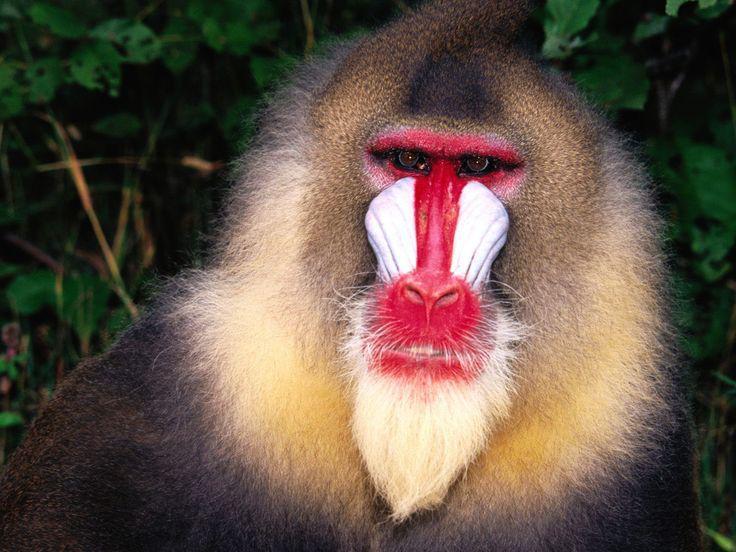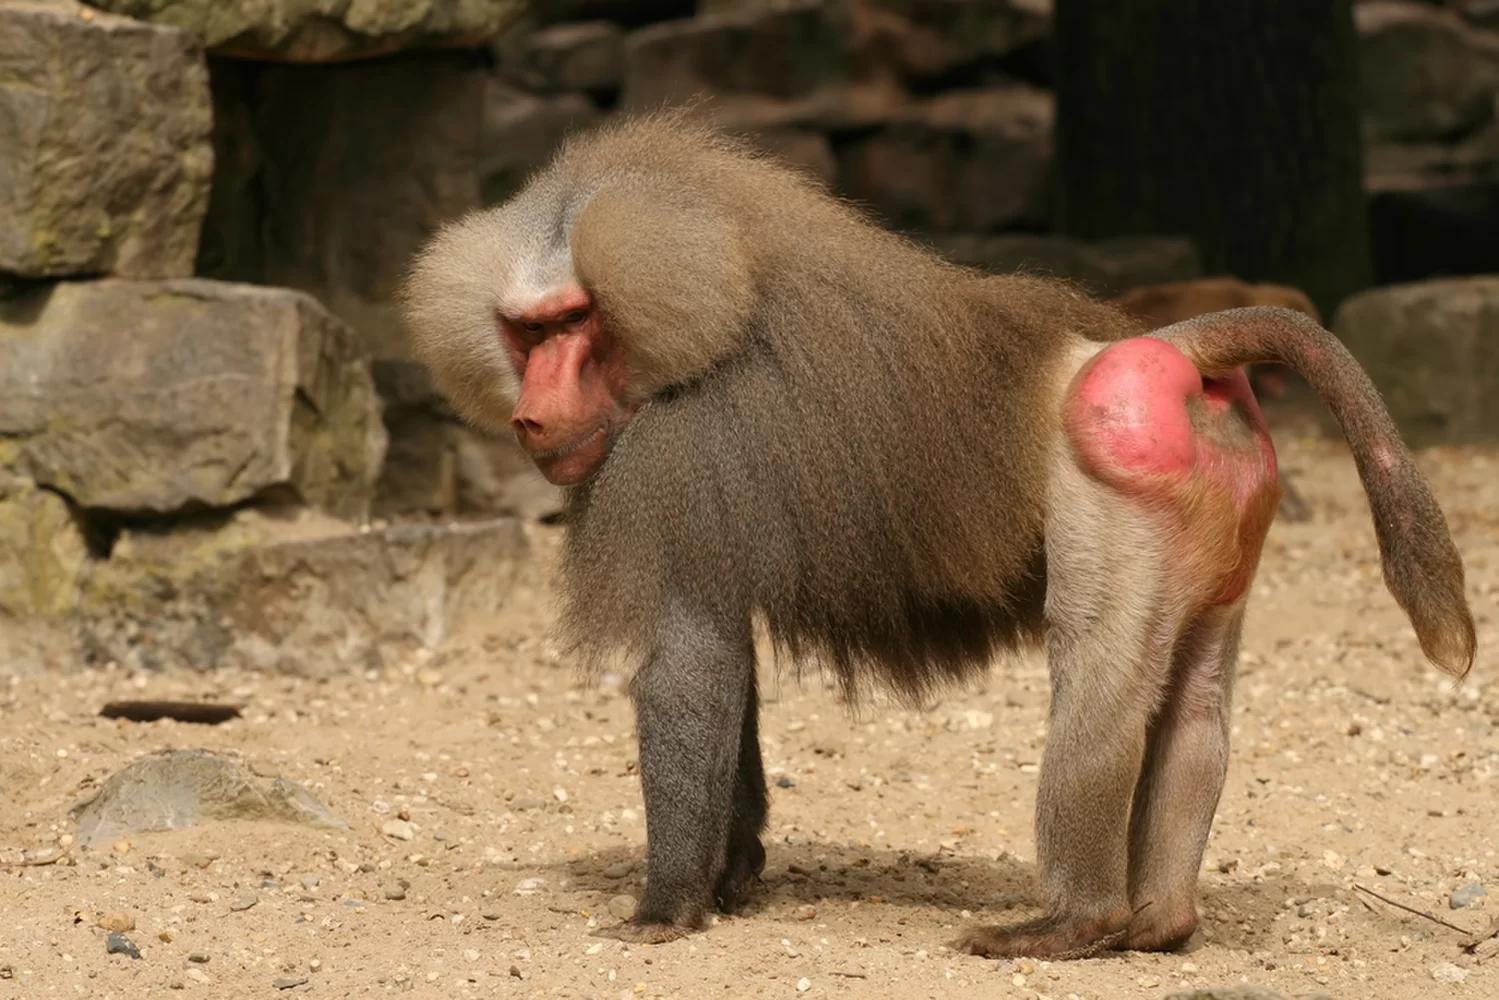The first image is the image on the left, the second image is the image on the right. Evaluate the accuracy of this statement regarding the images: "A baboon is standing on all fours with its tail and pink rear angled toward the camera and its head turned.". Is it true? Answer yes or no. Yes. The first image is the image on the left, the second image is the image on the right. For the images shown, is this caption "The left image contains exactly two baboons." true? Answer yes or no. No. 